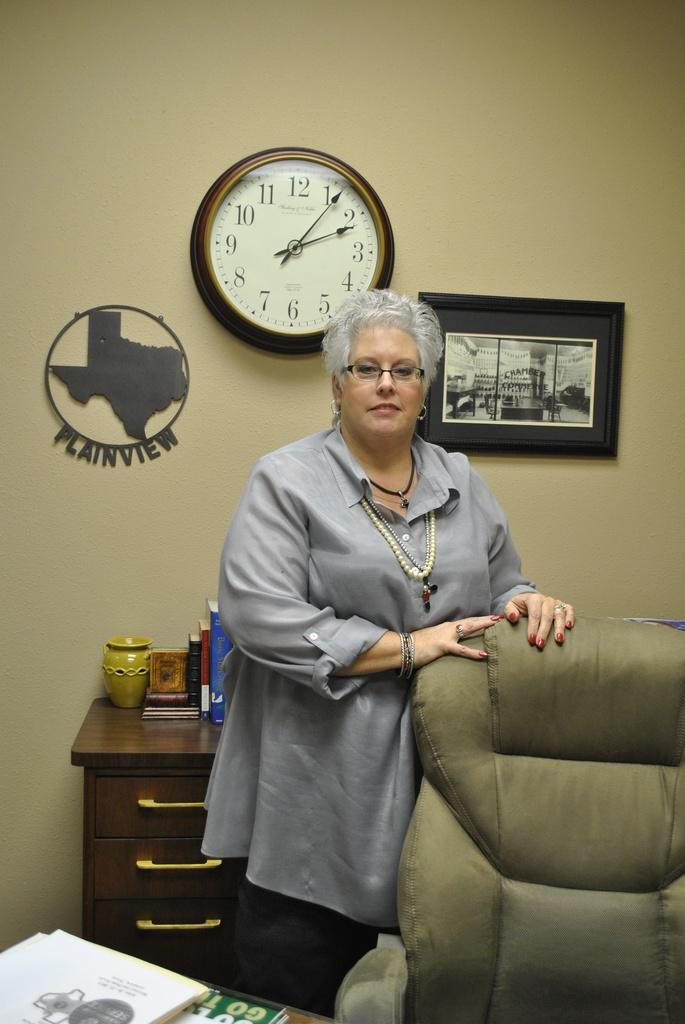<image>
Provide a brief description of the given image. A woman stands in front of a Texas plaque that says Plainview on it. 